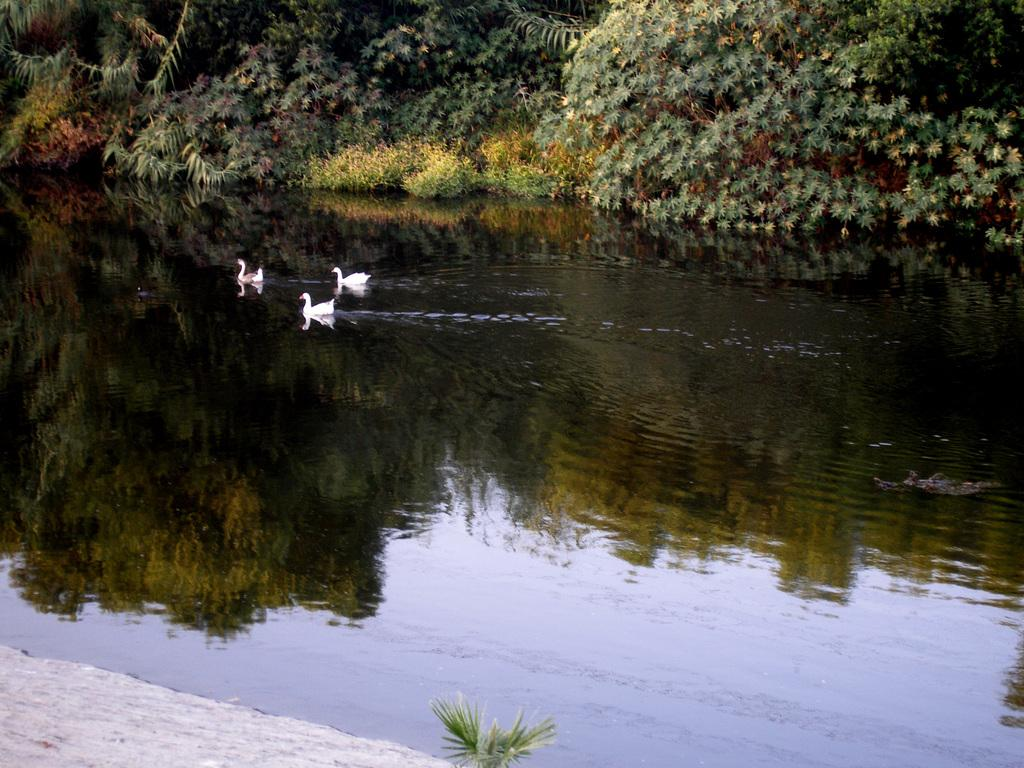How many birds can be seen in the image? There are three birds in the image. Where are the birds located? The birds are on the water. What color are the birds? The birds are white in color. What can be seen in the background of the image? There are many trees in the background of the image. What type of vegetation is visible in the water? Grass is visible in the water. What type of plastic is being used to support the birds in the image? There is no plastic visible in the image, and the birds are not being supported by any object. 